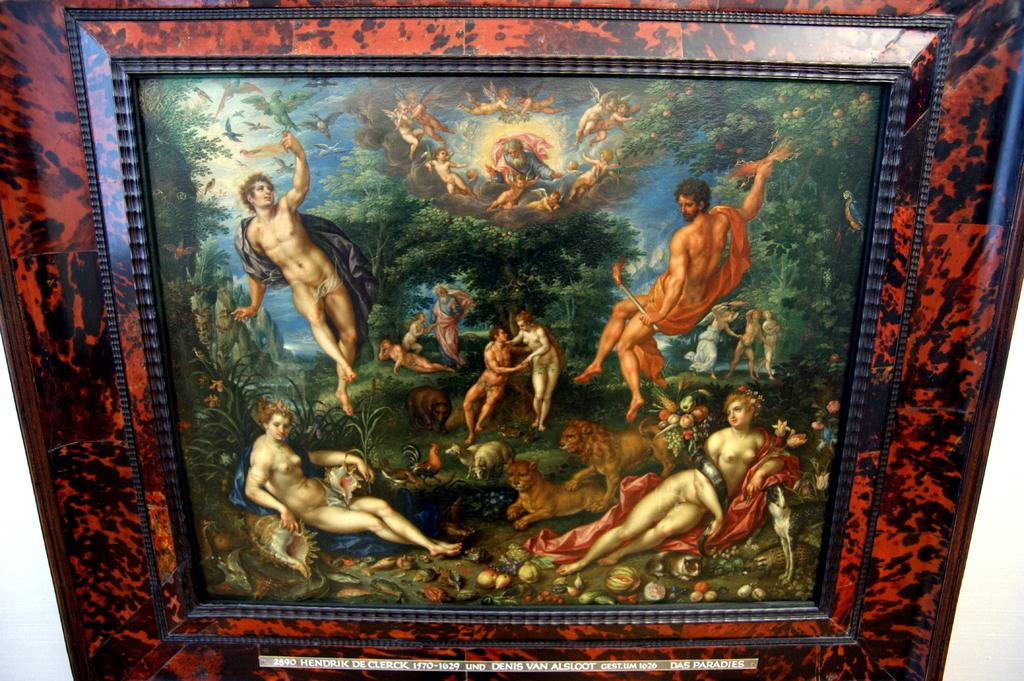<image>
Render a clear and concise summary of the photo. a biblical painting with the year 1570 at the bottom 